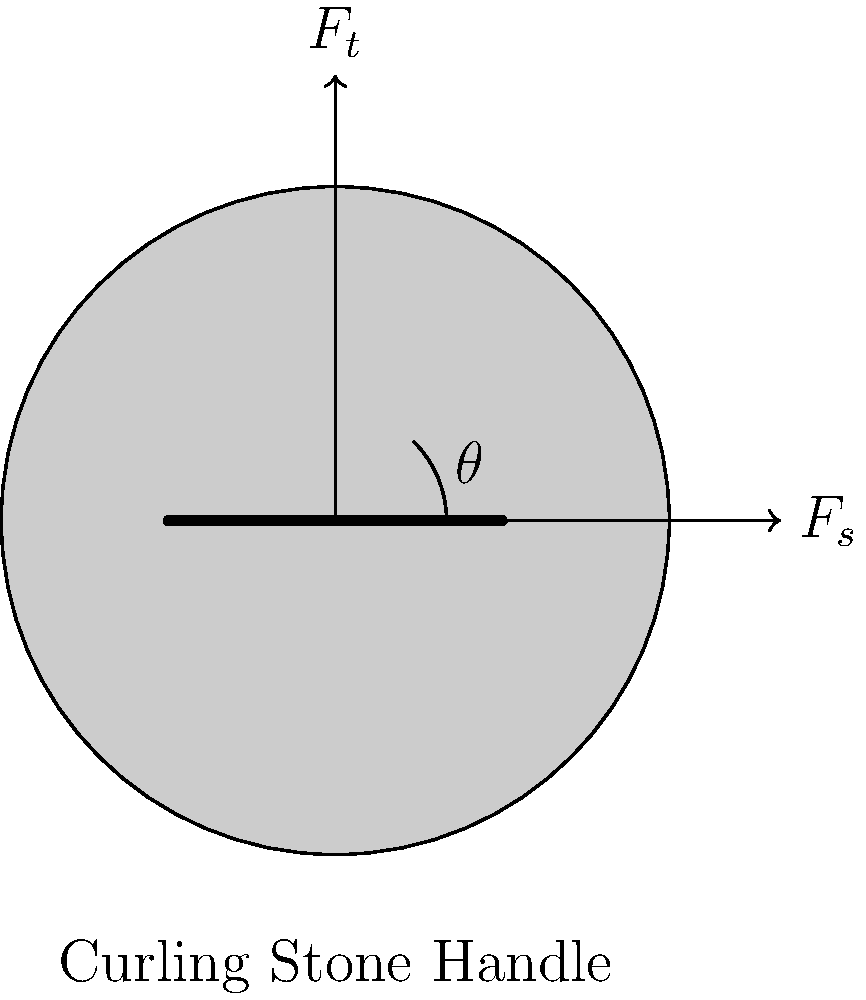In the structural design of a curling stone's handle, what is the relationship between the tensile force ($F_t$) and the shear force ($F_s$) acting on the handle when it's pulled at an angle $\theta$ to the horizontal? To understand the relationship between the tensile force ($F_t$) and shear force ($F_s$) acting on a curling stone's handle, we need to follow these steps:

1. Recognize that the total force ($F$) applied to the handle can be decomposed into two components: tensile force ($F_t$) and shear force ($F_s$).

2. The angle $\theta$ represents the angle between the applied force and the horizontal plane.

3. Using trigonometry, we can express the relationship between these forces:

   $F_t = F \sin(\theta)$
   $F_s = F \cos(\theta)$

4. To find the relationship between $F_t$ and $F_s$, we can divide these equations:

   $\frac{F_t}{F_s} = \frac{F \sin(\theta)}{F \cos(\theta)}$

5. The $F$ cancels out in the numerator and denominator, leaving us with:

   $\frac{F_t}{F_s} = \frac{\sin(\theta)}{\cos(\theta)}$

6. Recognize that $\frac{\sin(\theta)}{\cos(\theta)}$ is the definition of $\tan(\theta)$.

Therefore, the relationship between the tensile force and shear force can be expressed as:

$\frac{F_t}{F_s} = \tan(\theta)$

This means that the ratio of tensile force to shear force is equal to the tangent of the angle at which the handle is pulled.
Answer: $\frac{F_t}{F_s} = \tan(\theta)$ 